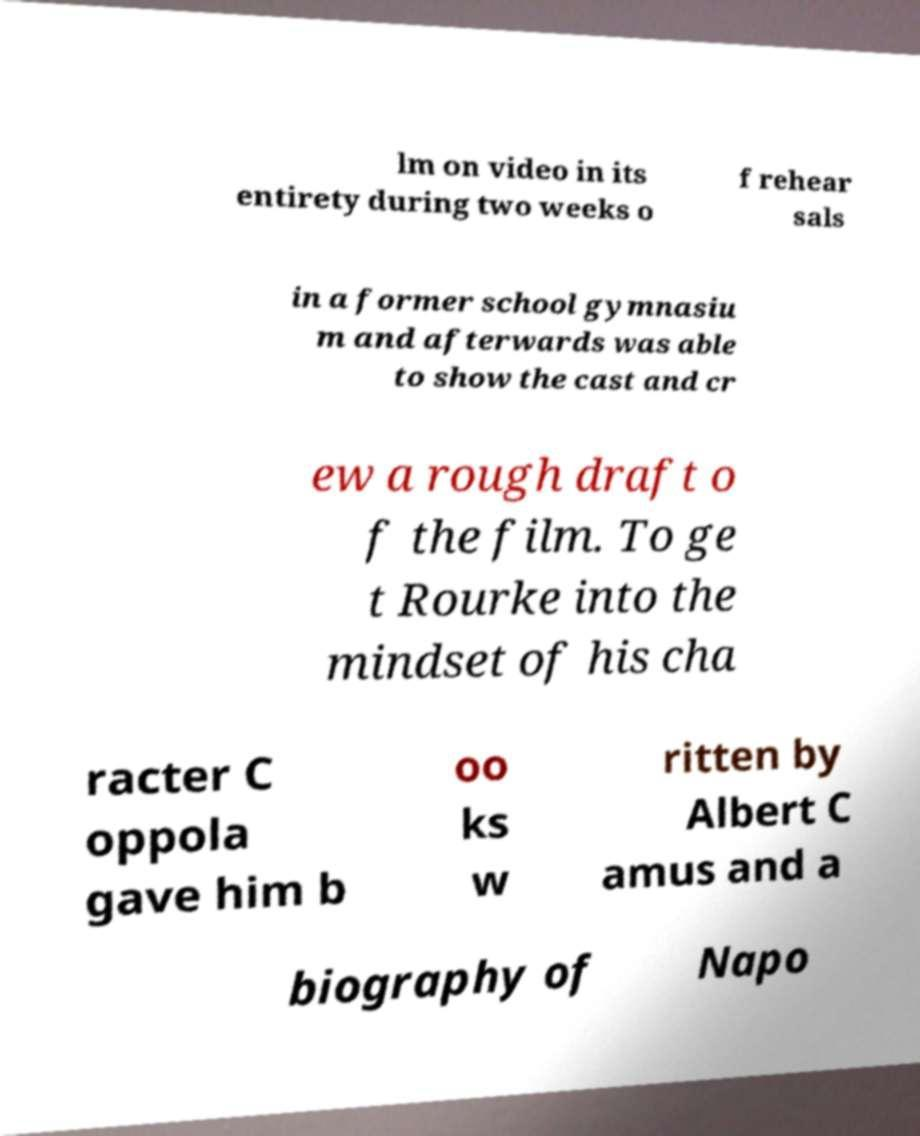There's text embedded in this image that I need extracted. Can you transcribe it verbatim? lm on video in its entirety during two weeks o f rehear sals in a former school gymnasiu m and afterwards was able to show the cast and cr ew a rough draft o f the film. To ge t Rourke into the mindset of his cha racter C oppola gave him b oo ks w ritten by Albert C amus and a biography of Napo 